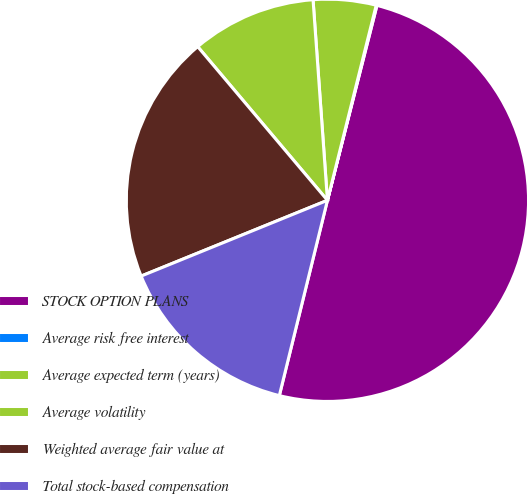Convert chart. <chart><loc_0><loc_0><loc_500><loc_500><pie_chart><fcel>STOCK OPTION PLANS<fcel>Average risk free interest<fcel>Average expected term (years)<fcel>Average volatility<fcel>Weighted average fair value at<fcel>Total stock-based compensation<nl><fcel>49.89%<fcel>0.06%<fcel>5.04%<fcel>10.02%<fcel>19.99%<fcel>15.01%<nl></chart> 